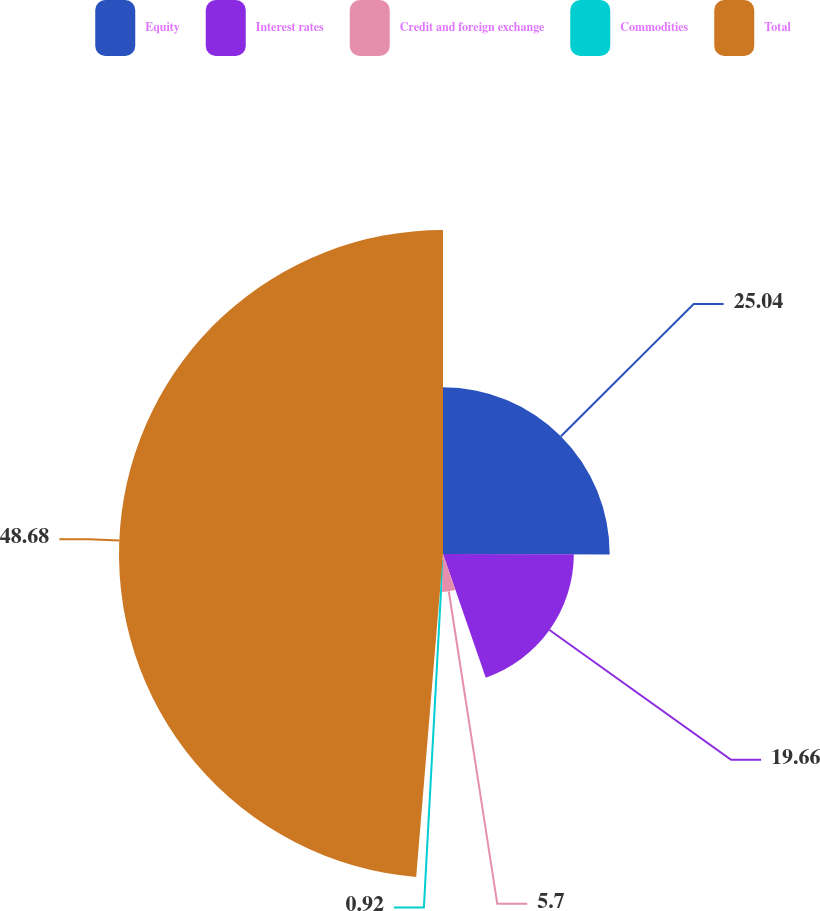<chart> <loc_0><loc_0><loc_500><loc_500><pie_chart><fcel>Equity<fcel>Interest rates<fcel>Credit and foreign exchange<fcel>Commodities<fcel>Total<nl><fcel>25.04%<fcel>19.66%<fcel>5.7%<fcel>0.92%<fcel>48.68%<nl></chart> 